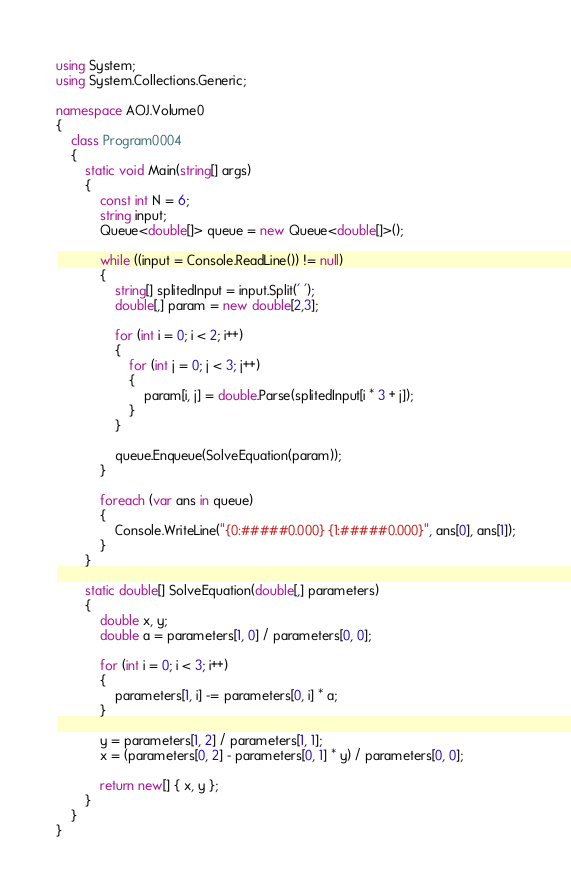<code> <loc_0><loc_0><loc_500><loc_500><_C#_>using System;
using System.Collections.Generic;

namespace AOJ.Volume0
{
    class Program0004
    {
        static void Main(string[] args)
        {
            const int N = 6;
            string input;
            Queue<double[]> queue = new Queue<double[]>();

            while ((input = Console.ReadLine()) != null)
            {
                string[] splitedInput = input.Split(' ');
                double[,] param = new double[2,3];

                for (int i = 0; i < 2; i++)
                {
                    for (int j = 0; j < 3; j++)
                    {
                        param[i, j] = double.Parse(splitedInput[i * 3 + j]);
                    }
                }

                queue.Enqueue(SolveEquation(param));
            }

            foreach (var ans in queue)
            {
                Console.WriteLine("{0:#####0.000} {1:#####0.000}", ans[0], ans[1]);
            }
        }

        static double[] SolveEquation(double[,] parameters)
        {
            double x, y;
            double a = parameters[1, 0] / parameters[0, 0];

            for (int i = 0; i < 3; i++)
            {
                parameters[1, i] -= parameters[0, i] * a;
            }

            y = parameters[1, 2] / parameters[1, 1];
            x = (parameters[0, 2] - parameters[0, 1] * y) / parameters[0, 0];

            return new[] { x, y };
        }
    }
}</code> 